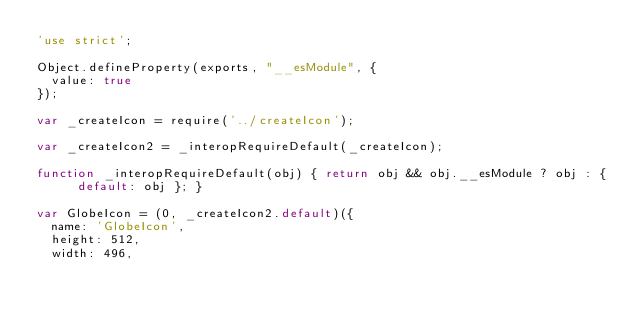<code> <loc_0><loc_0><loc_500><loc_500><_JavaScript_>'use strict';

Object.defineProperty(exports, "__esModule", {
  value: true
});

var _createIcon = require('../createIcon');

var _createIcon2 = _interopRequireDefault(_createIcon);

function _interopRequireDefault(obj) { return obj && obj.__esModule ? obj : { default: obj }; }

var GlobeIcon = (0, _createIcon2.default)({
  name: 'GlobeIcon',
  height: 512,
  width: 496,</code> 